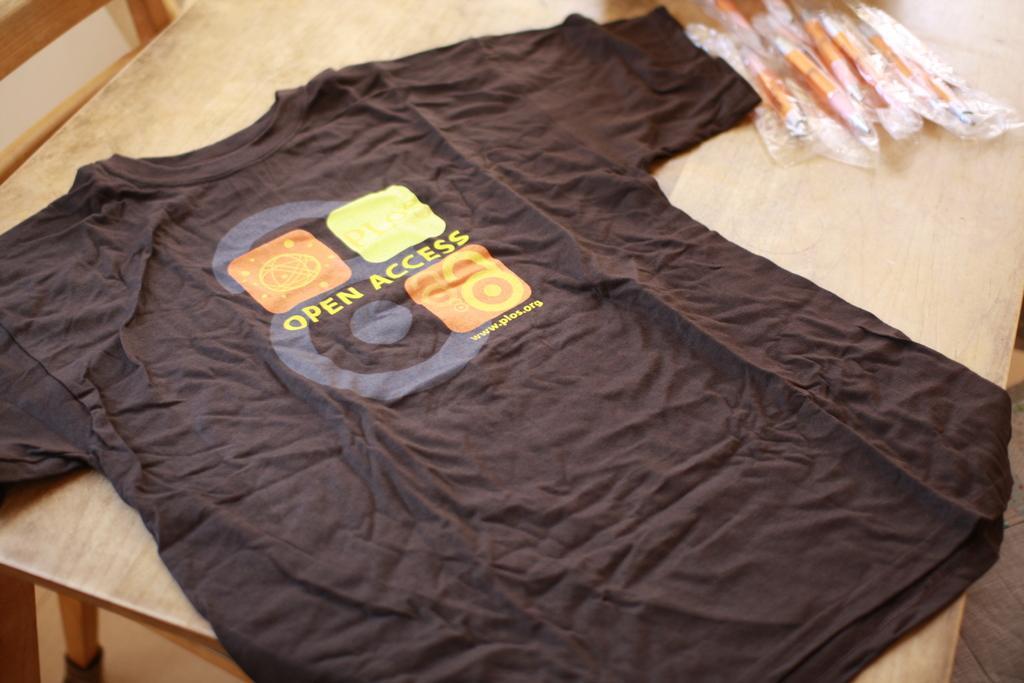How would you summarize this image in a sentence or two? In this picture a t shirt is placed on top of a table which is written as open lexus and to the right side of the image there are pens packed in a covers. 